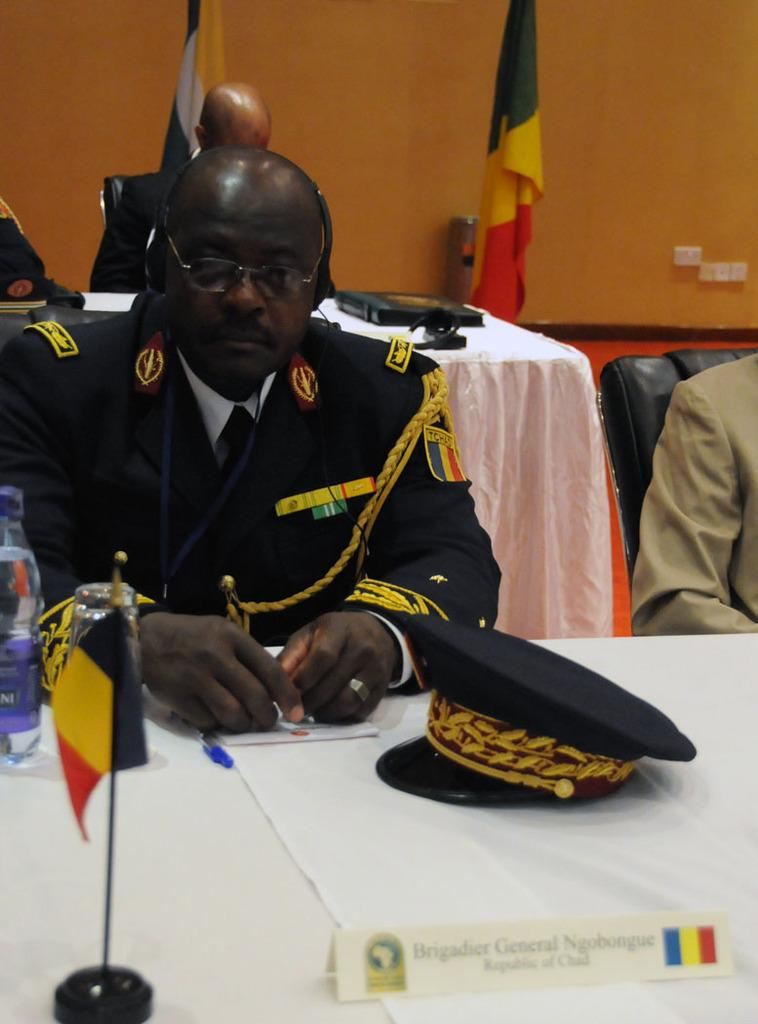What is the person in the image doing? The person is sitting in the image. What is the person wearing? The person is wearing a uniform. What can be seen on the person's head? There is a black cap in the image. What items are related to writing or documentation in the image? There is a paper and a pen in the image. What object is on a table in the image? There is a bottle on a table in the image. Can you describe the background of the image? There are other people and flags in the background of the image. What type of cattle can be seen resting in the image? There are no cattle or resting animals present in the image. 